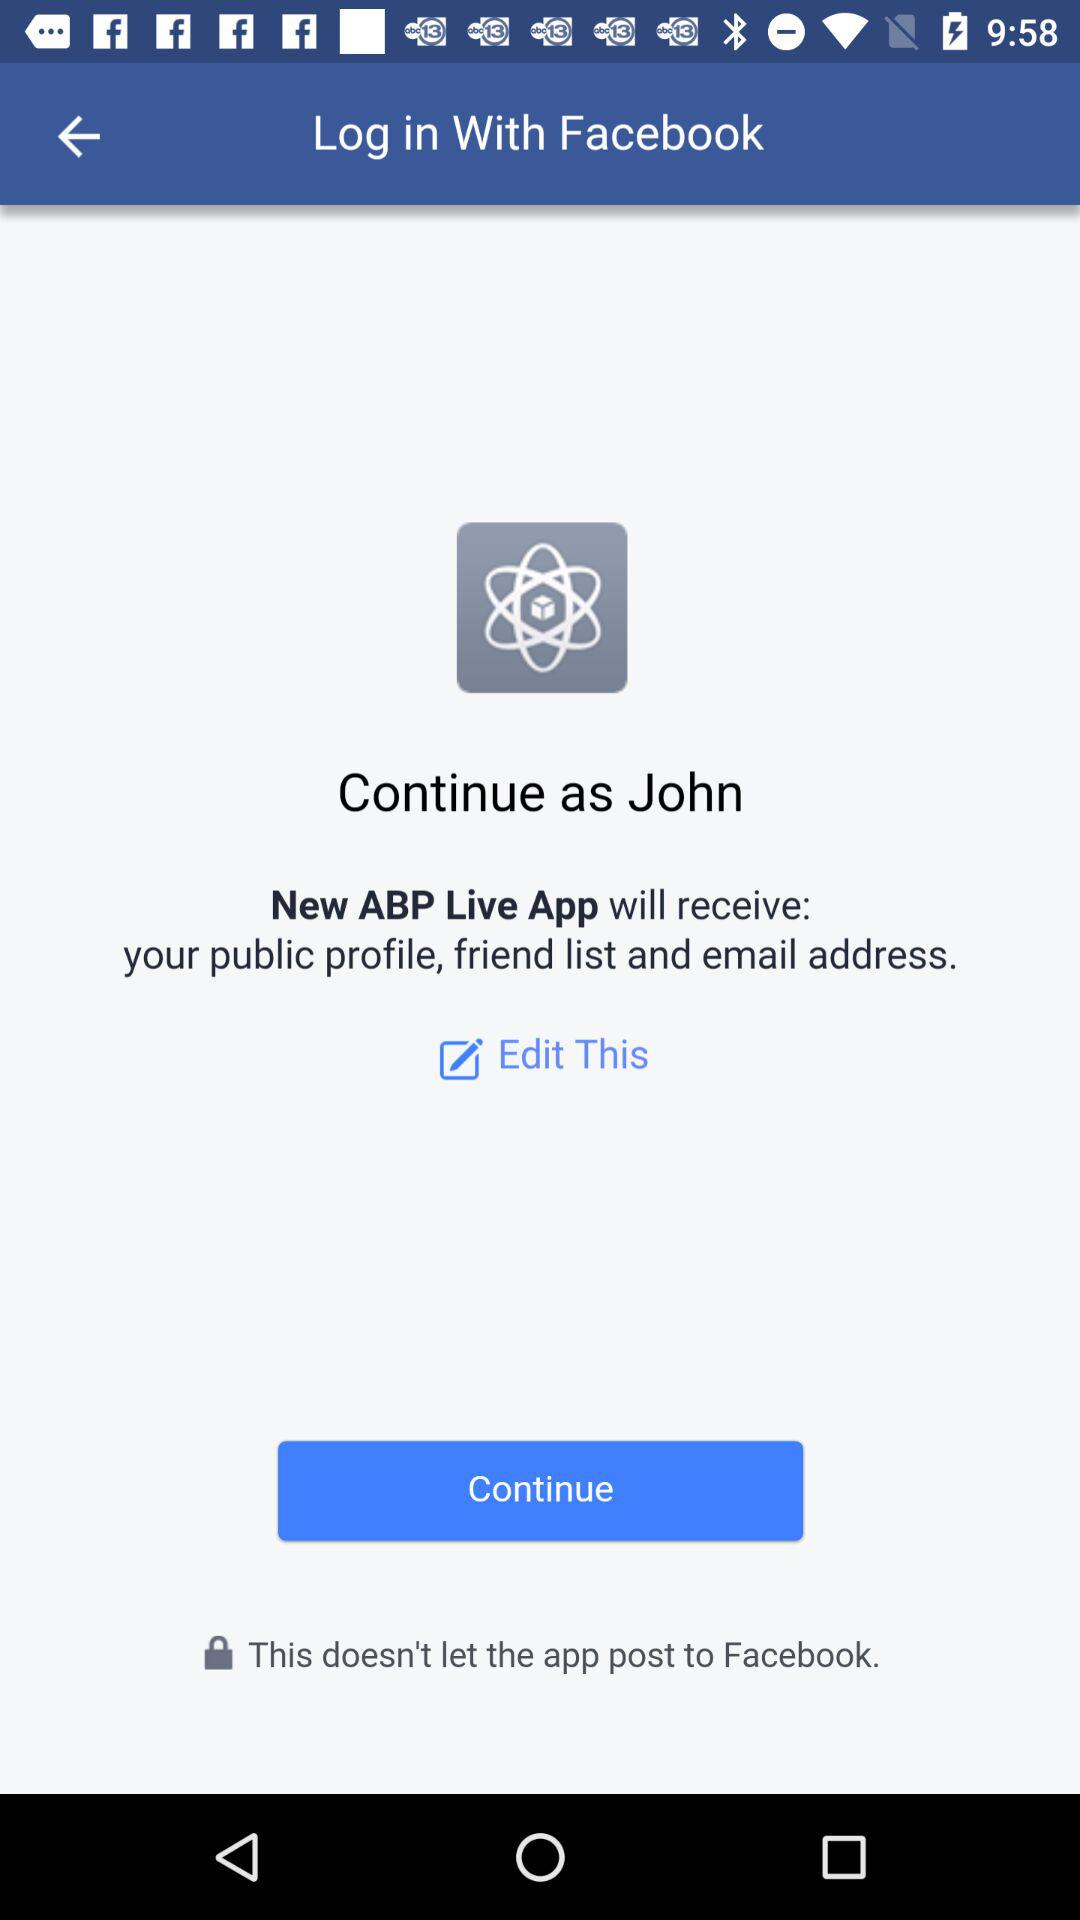What application is asking for permission? The application asking for permission is "New ABP Live App". 